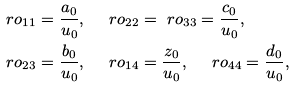Convert formula to latex. <formula><loc_0><loc_0><loc_500><loc_500>& \ r o _ { 1 1 } = \frac { a _ { 0 } } { u _ { 0 } } , \quad \ r o _ { 2 2 } = \ r o _ { 3 3 } = \frac { c _ { 0 } } { u _ { 0 } } , \\ & \ r o _ { 2 3 } = \frac { b _ { 0 } } { u _ { 0 } } , \quad \ r o _ { 1 4 } = \frac { z _ { 0 } } { u _ { 0 } } , \quad \ r o _ { 4 4 } = \frac { d _ { 0 } } { u _ { 0 } } ,</formula> 